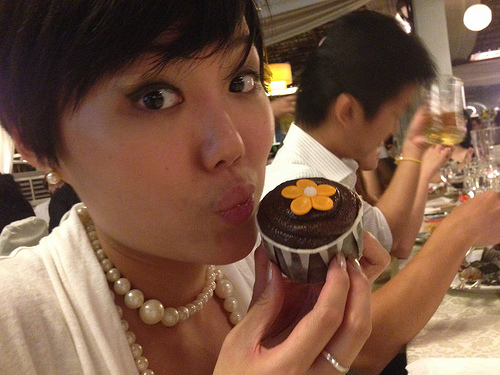Imagine the woman with the dessert narrating a story about her favorite dessert experience. What would she say? As she holds the cupcake up, she might begin her story with a smile:

'You know, this reminds me of my 10th birthday party. My mom baked the most incredible chocolate cake with layers of rich ganache. Each slice was an indulgence in itself, but what made it unforgettable was the special touch - she placed a single edible flower on each piece, just like this cupcake here! All these years later, whenever I see a flower on a dessert, it takes me right back to that moment - the warmth of family, the joy of that party, and the love that went into making every slice special."
Her eyes twinkle with nostalgia as she chuckles,
'Looks like tonight's dessert is going to be one of those memorable moments too!' 